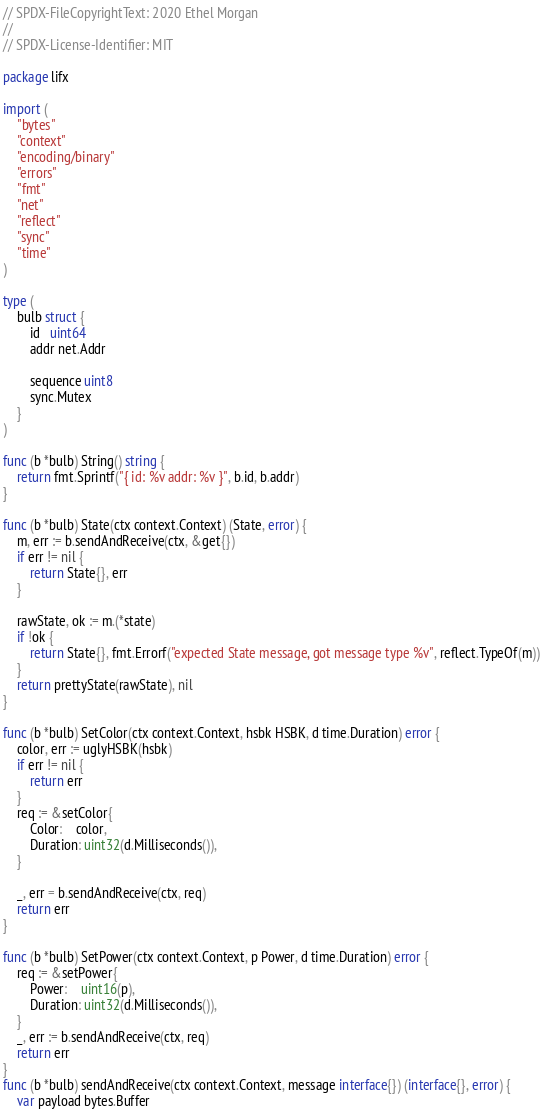<code> <loc_0><loc_0><loc_500><loc_500><_Go_>// SPDX-FileCopyrightText: 2020 Ethel Morgan
//
// SPDX-License-Identifier: MIT

package lifx

import (
	"bytes"
	"context"
	"encoding/binary"
	"errors"
	"fmt"
	"net"
	"reflect"
	"sync"
	"time"
)

type (
	bulb struct {
		id   uint64
		addr net.Addr

		sequence uint8
		sync.Mutex
	}
)

func (b *bulb) String() string {
	return fmt.Sprintf("{ id: %v addr: %v }", b.id, b.addr)
}

func (b *bulb) State(ctx context.Context) (State, error) {
	m, err := b.sendAndReceive(ctx, &get{})
	if err != nil {
		return State{}, err
	}

	rawState, ok := m.(*state)
	if !ok {
		return State{}, fmt.Errorf("expected State message, got message type %v", reflect.TypeOf(m))
	}
	return prettyState(rawState), nil
}

func (b *bulb) SetColor(ctx context.Context, hsbk HSBK, d time.Duration) error {
	color, err := uglyHSBK(hsbk)
	if err != nil {
		return err
	}
	req := &setColor{
		Color:    color,
		Duration: uint32(d.Milliseconds()),
	}

	_, err = b.sendAndReceive(ctx, req)
	return err
}

func (b *bulb) SetPower(ctx context.Context, p Power, d time.Duration) error {
	req := &setPower{
		Power:    uint16(p),
		Duration: uint32(d.Milliseconds()),
	}
	_, err := b.sendAndReceive(ctx, req)
	return err
}
func (b *bulb) sendAndReceive(ctx context.Context, message interface{}) (interface{}, error) {
	var payload bytes.Buffer</code> 